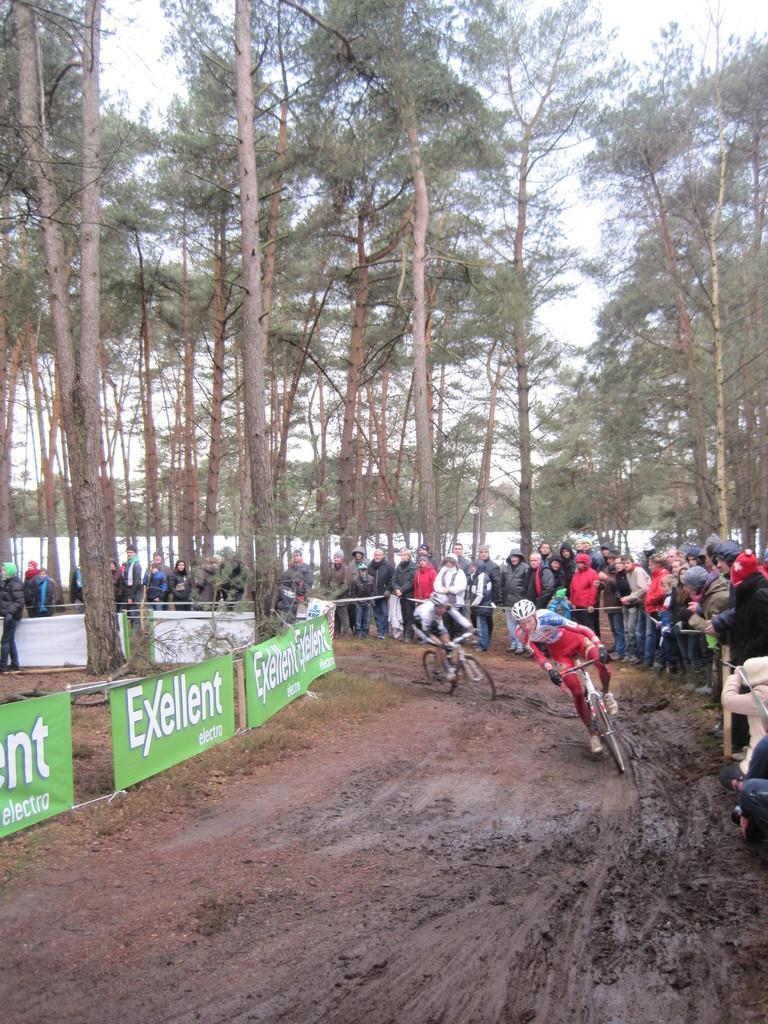Please provide a concise description of this image. In this picture there are two persons riding bicycle. There are group of people standing behind the fence. On the left side of the image there are banners. At the back there are trees. At the top there is sky. At the bottom there is mud. 